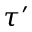Convert formula to latex. <formula><loc_0><loc_0><loc_500><loc_500>\tau ^ { \prime }</formula> 